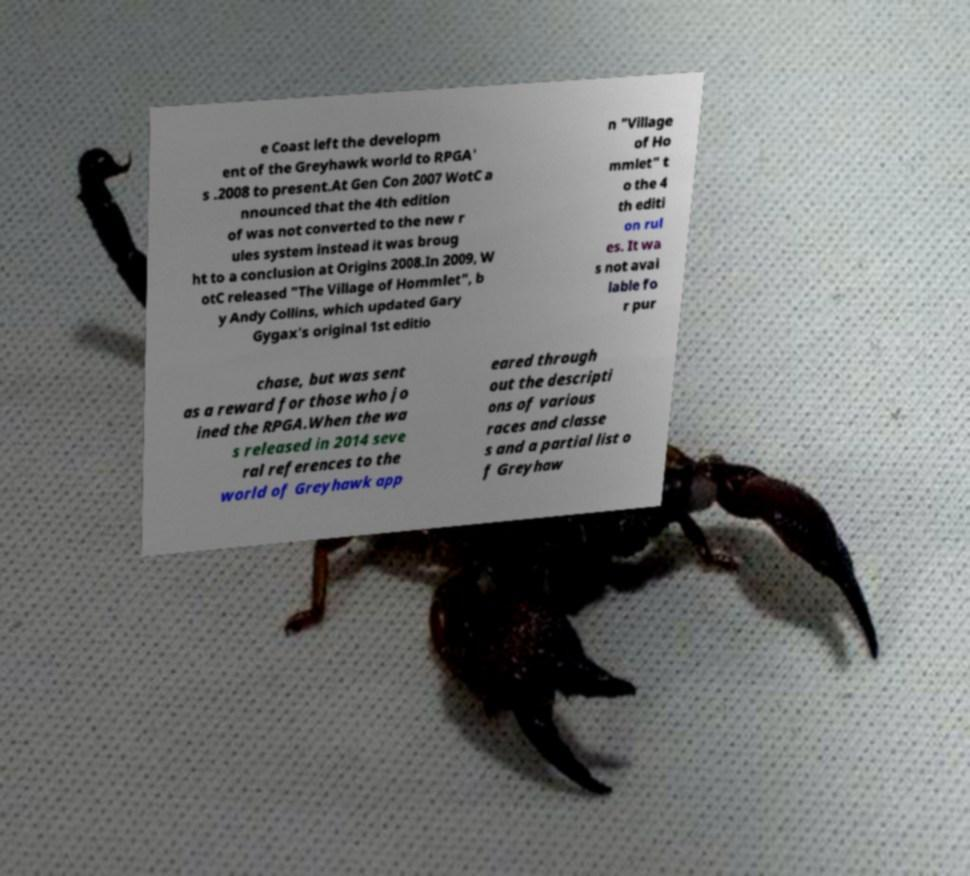What messages or text are displayed in this image? I need them in a readable, typed format. e Coast left the developm ent of the Greyhawk world to RPGA' s .2008 to present.At Gen Con 2007 WotC a nnounced that the 4th edition of was not converted to the new r ules system instead it was broug ht to a conclusion at Origins 2008.In 2009, W otC released "The Village of Hommlet", b y Andy Collins, which updated Gary Gygax's original 1st editio n "Village of Ho mmlet" t o the 4 th editi on rul es. It wa s not avai lable fo r pur chase, but was sent as a reward for those who jo ined the RPGA.When the wa s released in 2014 seve ral references to the world of Greyhawk app eared through out the descripti ons of various races and classe s and a partial list o f Greyhaw 